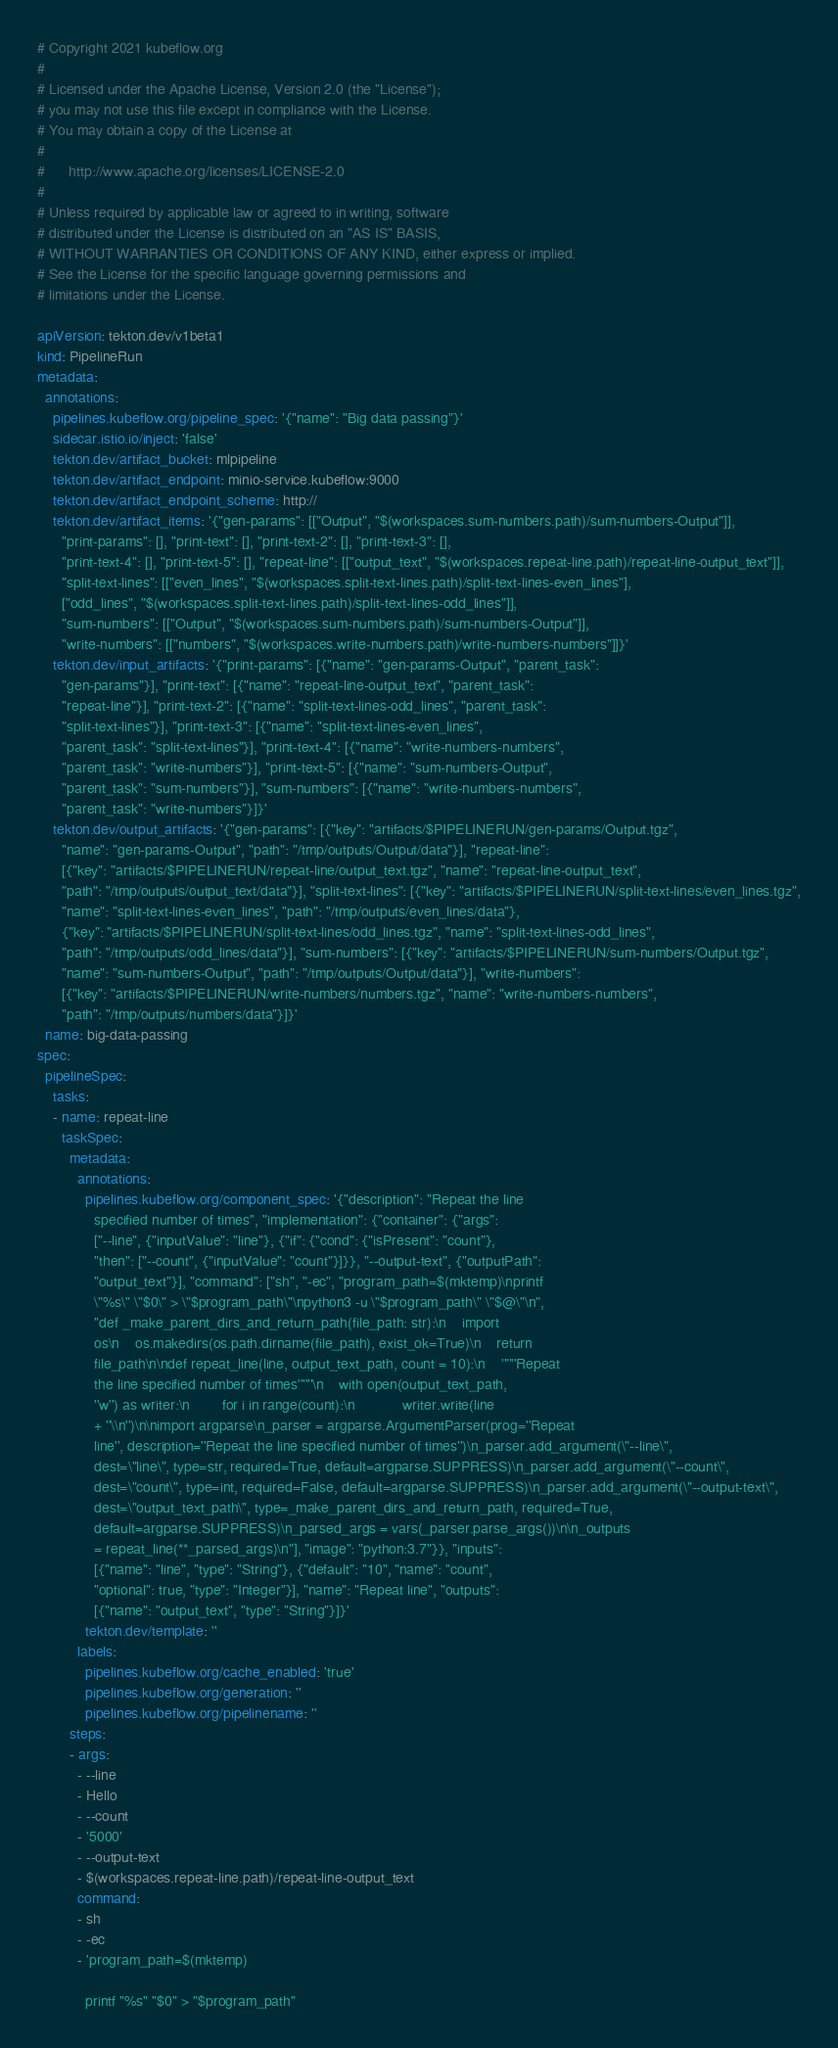Convert code to text. <code><loc_0><loc_0><loc_500><loc_500><_YAML_># Copyright 2021 kubeflow.org
#
# Licensed under the Apache License, Version 2.0 (the "License");
# you may not use this file except in compliance with the License.
# You may obtain a copy of the License at
#
#      http://www.apache.org/licenses/LICENSE-2.0
#
# Unless required by applicable law or agreed to in writing, software
# distributed under the License is distributed on an "AS IS" BASIS,
# WITHOUT WARRANTIES OR CONDITIONS OF ANY KIND, either express or implied.
# See the License for the specific language governing permissions and
# limitations under the License.

apiVersion: tekton.dev/v1beta1
kind: PipelineRun
metadata:
  annotations:
    pipelines.kubeflow.org/pipeline_spec: '{"name": "Big data passing"}'
    sidecar.istio.io/inject: 'false'
    tekton.dev/artifact_bucket: mlpipeline
    tekton.dev/artifact_endpoint: minio-service.kubeflow:9000
    tekton.dev/artifact_endpoint_scheme: http://
    tekton.dev/artifact_items: '{"gen-params": [["Output", "$(workspaces.sum-numbers.path)/sum-numbers-Output"]],
      "print-params": [], "print-text": [], "print-text-2": [], "print-text-3": [],
      "print-text-4": [], "print-text-5": [], "repeat-line": [["output_text", "$(workspaces.repeat-line.path)/repeat-line-output_text"]],
      "split-text-lines": [["even_lines", "$(workspaces.split-text-lines.path)/split-text-lines-even_lines"],
      ["odd_lines", "$(workspaces.split-text-lines.path)/split-text-lines-odd_lines"]],
      "sum-numbers": [["Output", "$(workspaces.sum-numbers.path)/sum-numbers-Output"]],
      "write-numbers": [["numbers", "$(workspaces.write-numbers.path)/write-numbers-numbers"]]}'
    tekton.dev/input_artifacts: '{"print-params": [{"name": "gen-params-Output", "parent_task":
      "gen-params"}], "print-text": [{"name": "repeat-line-output_text", "parent_task":
      "repeat-line"}], "print-text-2": [{"name": "split-text-lines-odd_lines", "parent_task":
      "split-text-lines"}], "print-text-3": [{"name": "split-text-lines-even_lines",
      "parent_task": "split-text-lines"}], "print-text-4": [{"name": "write-numbers-numbers",
      "parent_task": "write-numbers"}], "print-text-5": [{"name": "sum-numbers-Output",
      "parent_task": "sum-numbers"}], "sum-numbers": [{"name": "write-numbers-numbers",
      "parent_task": "write-numbers"}]}'
    tekton.dev/output_artifacts: '{"gen-params": [{"key": "artifacts/$PIPELINERUN/gen-params/Output.tgz",
      "name": "gen-params-Output", "path": "/tmp/outputs/Output/data"}], "repeat-line":
      [{"key": "artifacts/$PIPELINERUN/repeat-line/output_text.tgz", "name": "repeat-line-output_text",
      "path": "/tmp/outputs/output_text/data"}], "split-text-lines": [{"key": "artifacts/$PIPELINERUN/split-text-lines/even_lines.tgz",
      "name": "split-text-lines-even_lines", "path": "/tmp/outputs/even_lines/data"},
      {"key": "artifacts/$PIPELINERUN/split-text-lines/odd_lines.tgz", "name": "split-text-lines-odd_lines",
      "path": "/tmp/outputs/odd_lines/data"}], "sum-numbers": [{"key": "artifacts/$PIPELINERUN/sum-numbers/Output.tgz",
      "name": "sum-numbers-Output", "path": "/tmp/outputs/Output/data"}], "write-numbers":
      [{"key": "artifacts/$PIPELINERUN/write-numbers/numbers.tgz", "name": "write-numbers-numbers",
      "path": "/tmp/outputs/numbers/data"}]}'
  name: big-data-passing
spec:
  pipelineSpec:
    tasks:
    - name: repeat-line
      taskSpec:
        metadata:
          annotations:
            pipelines.kubeflow.org/component_spec: '{"description": "Repeat the line
              specified number of times", "implementation": {"container": {"args":
              ["--line", {"inputValue": "line"}, {"if": {"cond": {"isPresent": "count"},
              "then": ["--count", {"inputValue": "count"}]}}, "--output-text", {"outputPath":
              "output_text"}], "command": ["sh", "-ec", "program_path=$(mktemp)\nprintf
              \"%s\" \"$0\" > \"$program_path\"\npython3 -u \"$program_path\" \"$@\"\n",
              "def _make_parent_dirs_and_return_path(file_path: str):\n    import
              os\n    os.makedirs(os.path.dirname(file_path), exist_ok=True)\n    return
              file_path\n\ndef repeat_line(line, output_text_path, count = 10):\n    ''''''Repeat
              the line specified number of times''''''\n    with open(output_text_path,
              ''w'') as writer:\n        for i in range(count):\n            writer.write(line
              + ''\\n'')\n\nimport argparse\n_parser = argparse.ArgumentParser(prog=''Repeat
              line'', description=''Repeat the line specified number of times'')\n_parser.add_argument(\"--line\",
              dest=\"line\", type=str, required=True, default=argparse.SUPPRESS)\n_parser.add_argument(\"--count\",
              dest=\"count\", type=int, required=False, default=argparse.SUPPRESS)\n_parser.add_argument(\"--output-text\",
              dest=\"output_text_path\", type=_make_parent_dirs_and_return_path, required=True,
              default=argparse.SUPPRESS)\n_parsed_args = vars(_parser.parse_args())\n\n_outputs
              = repeat_line(**_parsed_args)\n"], "image": "python:3.7"}}, "inputs":
              [{"name": "line", "type": "String"}, {"default": "10", "name": "count",
              "optional": true, "type": "Integer"}], "name": "Repeat line", "outputs":
              [{"name": "output_text", "type": "String"}]}'
            tekton.dev/template: ''
          labels:
            pipelines.kubeflow.org/cache_enabled: 'true'
            pipelines.kubeflow.org/generation: ''
            pipelines.kubeflow.org/pipelinename: ''
        steps:
        - args:
          - --line
          - Hello
          - --count
          - '5000'
          - --output-text
          - $(workspaces.repeat-line.path)/repeat-line-output_text
          command:
          - sh
          - -ec
          - 'program_path=$(mktemp)

            printf "%s" "$0" > "$program_path"
</code> 